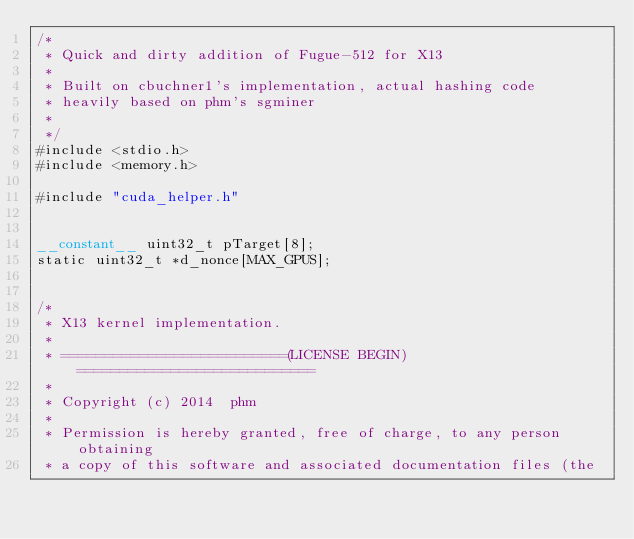<code> <loc_0><loc_0><loc_500><loc_500><_Cuda_>/*
 * Quick and dirty addition of Fugue-512 for X13
 * 
 * Built on cbuchner1's implementation, actual hashing code
 * heavily based on phm's sgminer
 *
 */
#include <stdio.h>
#include <memory.h>

#include "cuda_helper.h"


__constant__ uint32_t pTarget[8];
static uint32_t *d_nonce[MAX_GPUS];


/*
 * X13 kernel implementation.
 *
 * ==========================(LICENSE BEGIN)============================
 *
 * Copyright (c) 2014  phm
 * 
 * Permission is hereby granted, free of charge, to any person obtaining
 * a copy of this software and associated documentation files (the</code> 